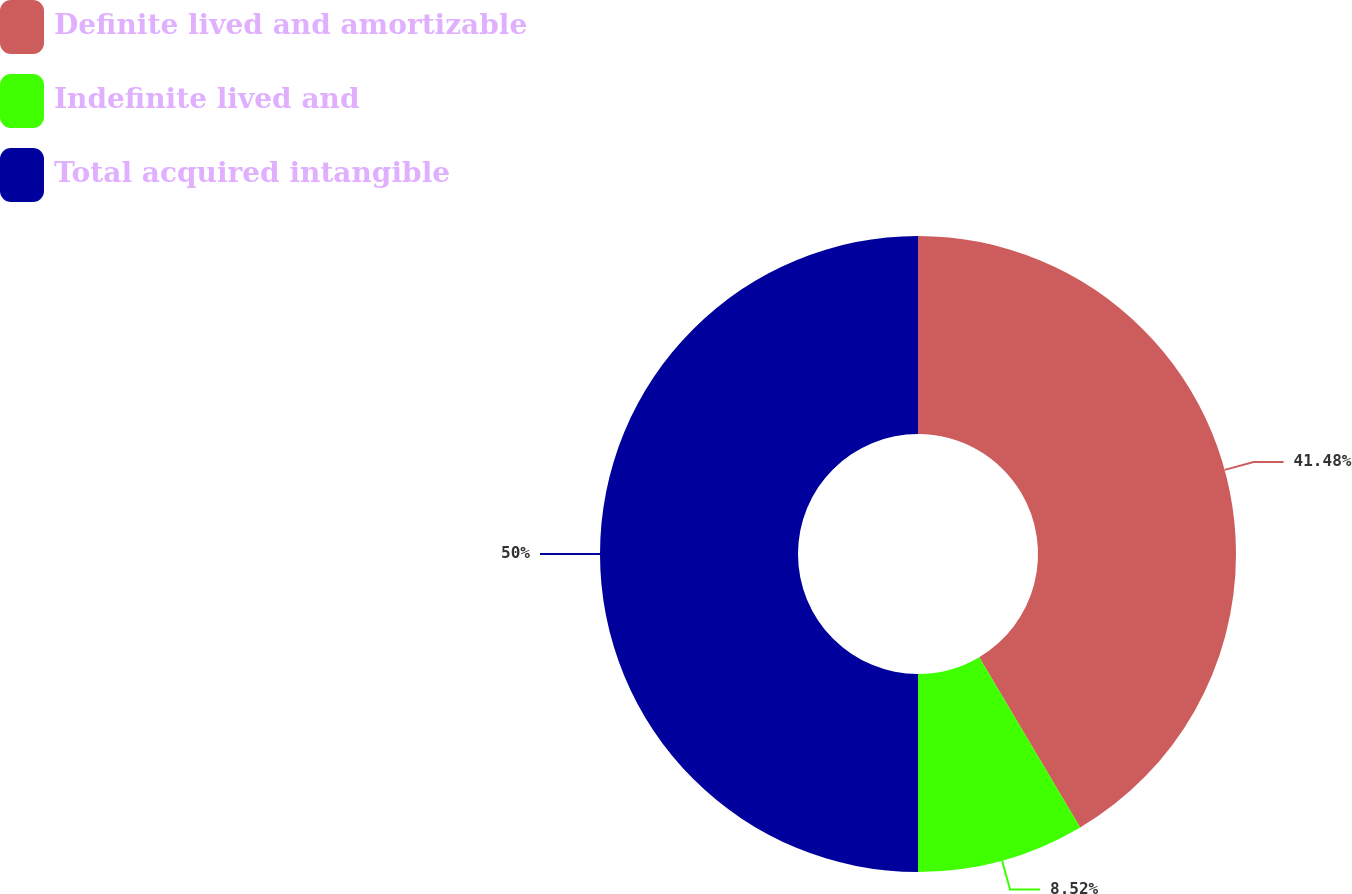<chart> <loc_0><loc_0><loc_500><loc_500><pie_chart><fcel>Definite lived and amortizable<fcel>Indefinite lived and<fcel>Total acquired intangible<nl><fcel>41.48%<fcel>8.52%<fcel>50.0%<nl></chart> 